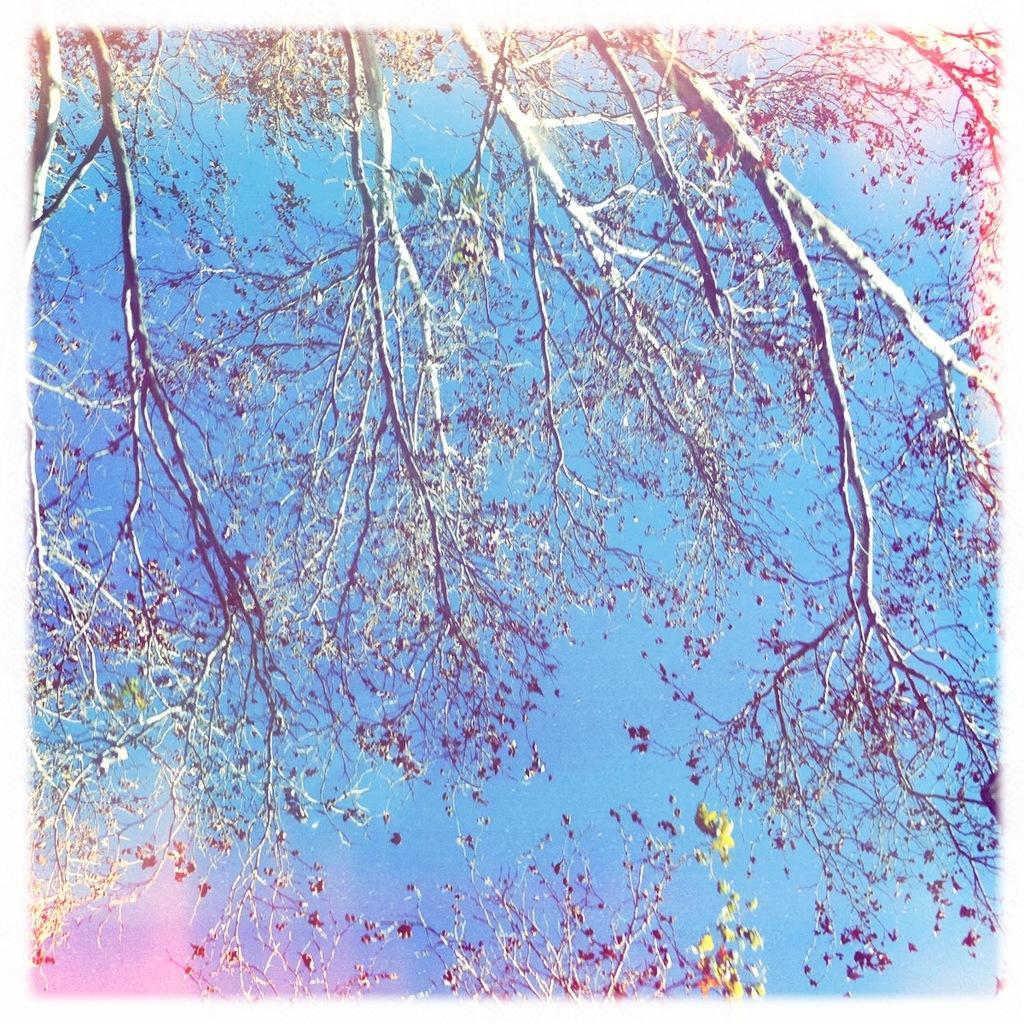In one or two sentences, can you explain what this image depicts? In this image we can see some trees. In the background of the image there is the sky. 